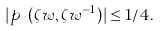<formula> <loc_0><loc_0><loc_500><loc_500>| p _ { n } ( \zeta w , \zeta w ^ { - 1 } ) | \leq 1 / 4 .</formula> 